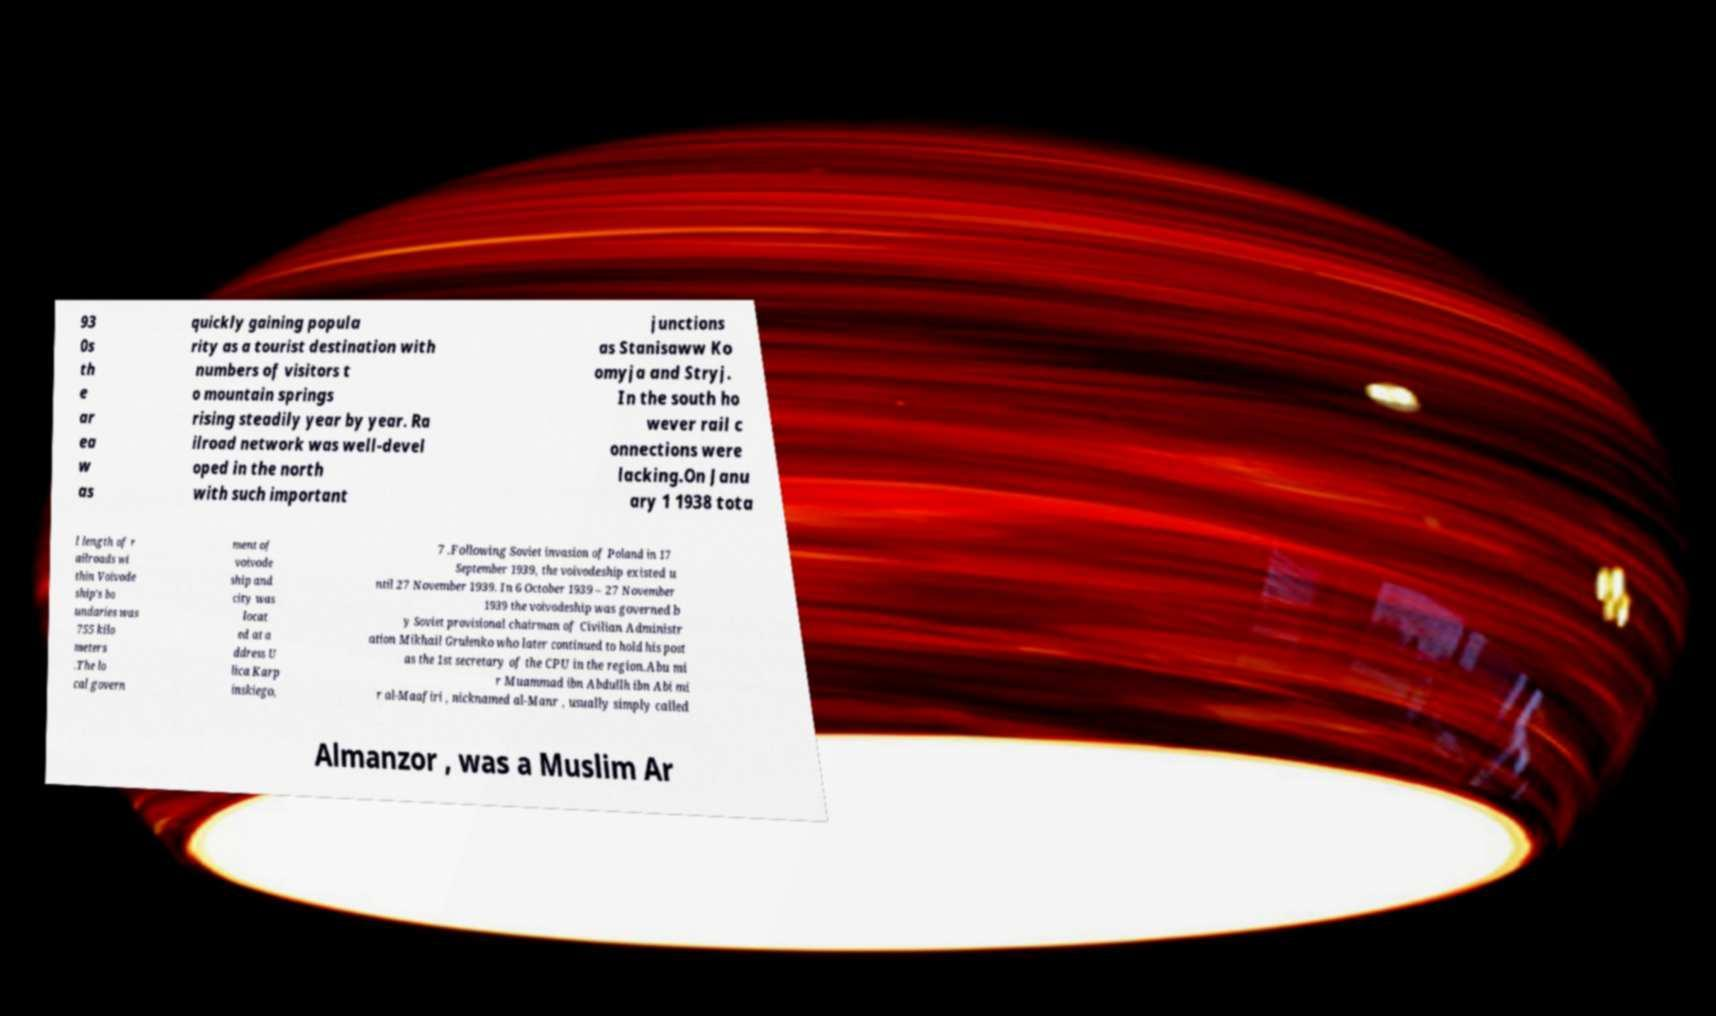Can you read and provide the text displayed in the image?This photo seems to have some interesting text. Can you extract and type it out for me? 93 0s th e ar ea w as quickly gaining popula rity as a tourist destination with numbers of visitors t o mountain springs rising steadily year by year. Ra ilroad network was well-devel oped in the north with such important junctions as Stanisaww Ko omyja and Stryj. In the south ho wever rail c onnections were lacking.On Janu ary 1 1938 tota l length of r ailroads wi thin Voivode ship's bo undaries was 755 kilo meters .The lo cal govern ment of voivode ship and city was locat ed at a ddress U lica Karp inskiego, 7 .Following Soviet invasion of Poland in 17 September 1939, the voivodeship existed u ntil 27 November 1939. In 6 October 1939 – 27 November 1939 the voivodeship was governed b y Soviet provisional chairman of Civilian Administr ation Mikhail Grulenko who later continued to hold his post as the 1st secretary of the CPU in the region.Abu mi r Muammad ibn Abdullh ibn Abi mi r al-Maafiri , nicknamed al-Manr , usually simply called Almanzor , was a Muslim Ar 